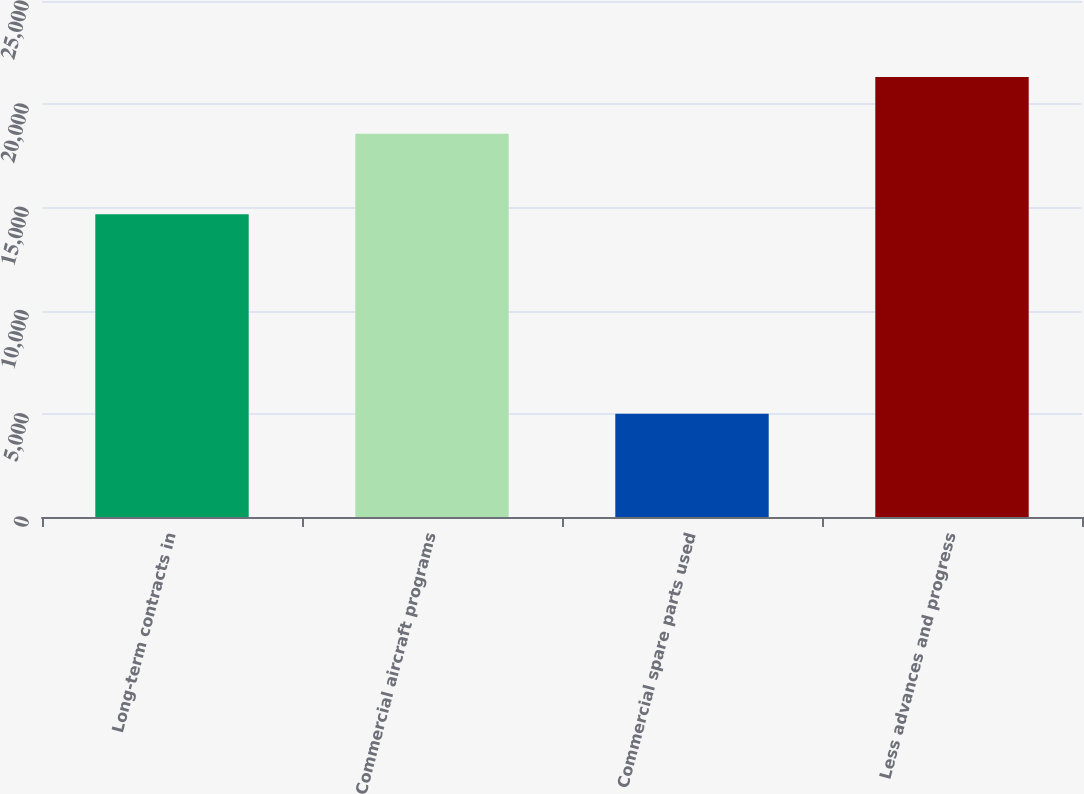Convert chart to OTSL. <chart><loc_0><loc_0><loc_500><loc_500><bar_chart><fcel>Long-term contracts in<fcel>Commercial aircraft programs<fcel>Commercial spare parts used<fcel>Less advances and progress<nl><fcel>14673<fcel>18568<fcel>5004<fcel>21312<nl></chart> 